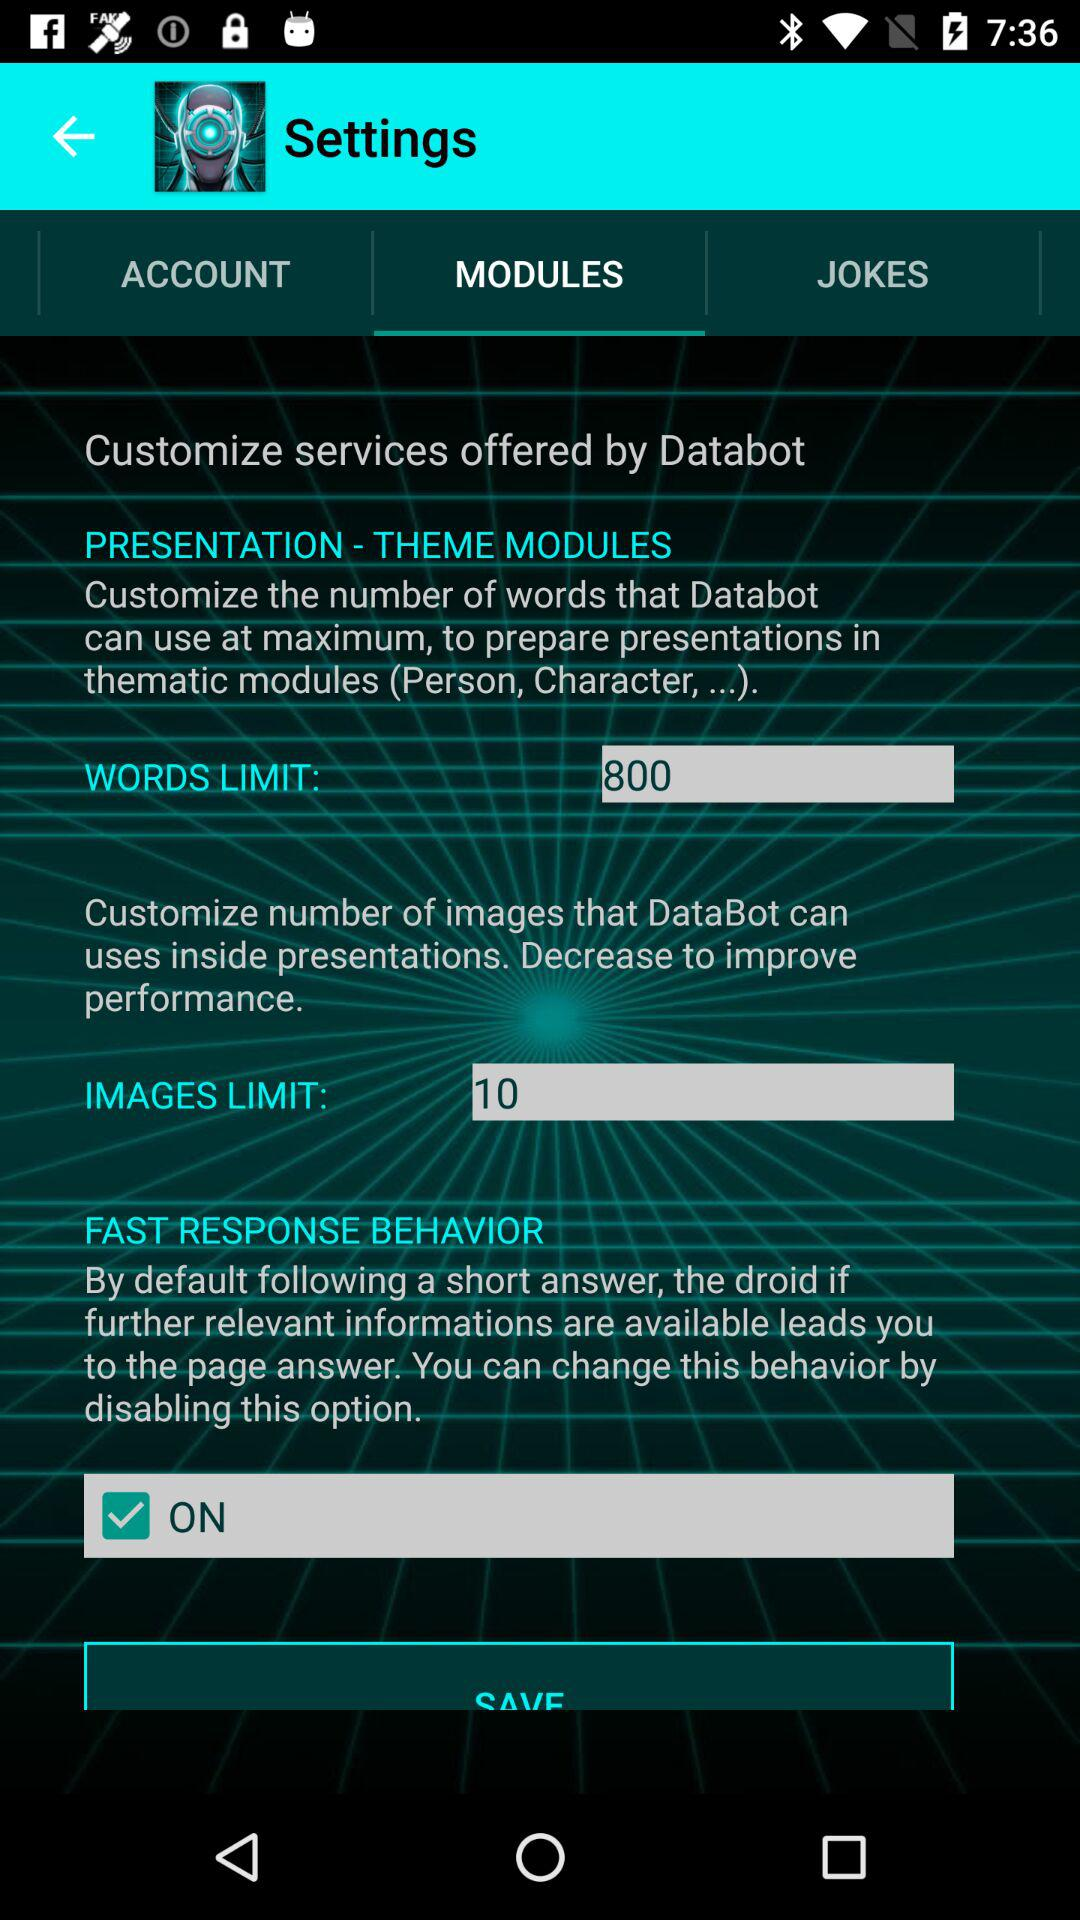Which tab is selected? The selected tab is "MODULES". 